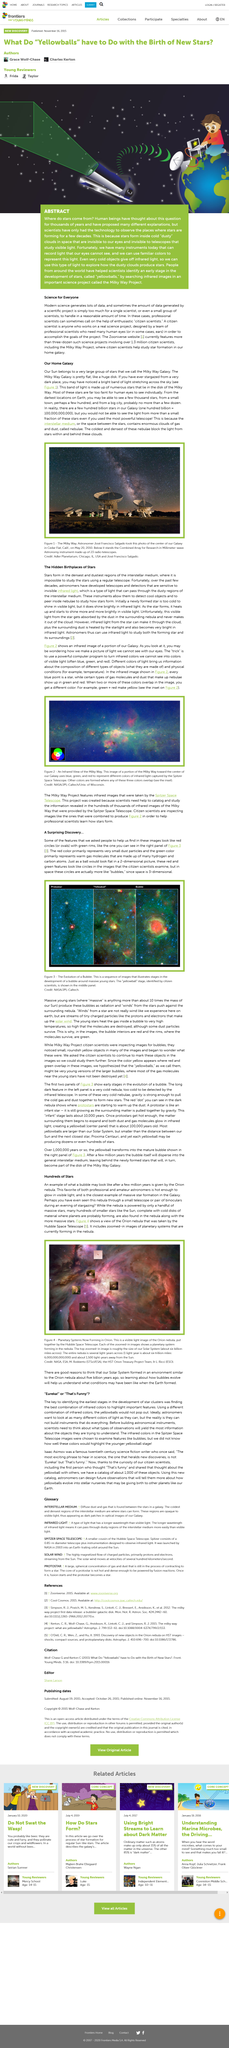Indicate a few pertinent items in this graphic. In three-dimensional space, circles appear as bubbles that possess a round, hollow shape with uniform thickness throughout their circumference. Hydrogen and carbon atoms make up the warm gas molecules. The phrase 'Eureka' is only used in the title and not in the article. Astronomers are eager to observe a diverse range of colors of light in the universe. The red color circles represent small dust particles. 